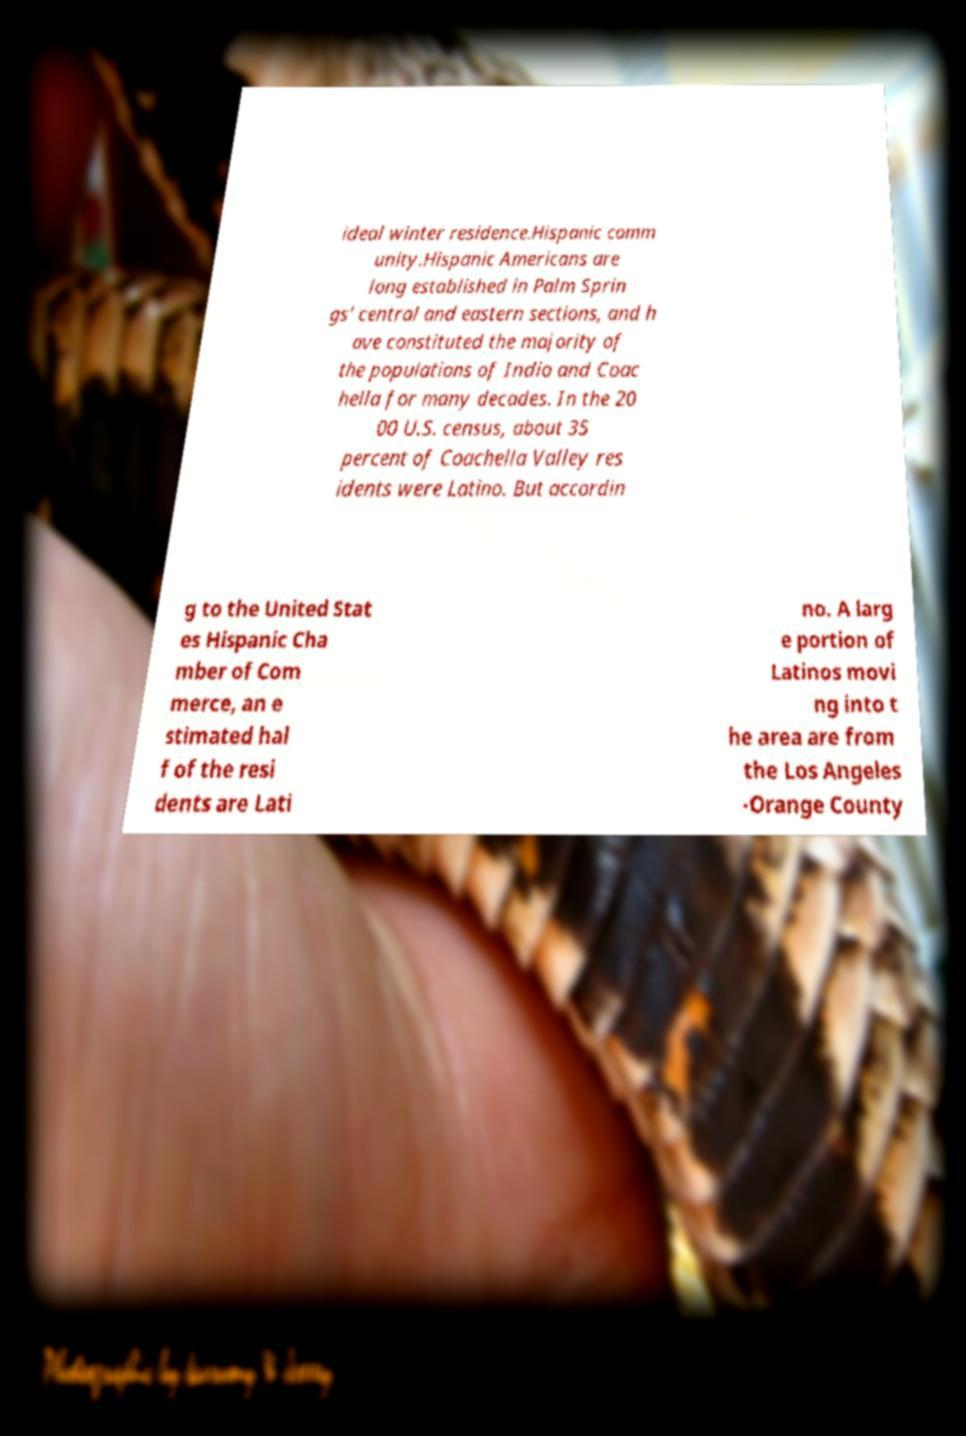I need the written content from this picture converted into text. Can you do that? ideal winter residence.Hispanic comm unity.Hispanic Americans are long established in Palm Sprin gs' central and eastern sections, and h ave constituted the majority of the populations of Indio and Coac hella for many decades. In the 20 00 U.S. census, about 35 percent of Coachella Valley res idents were Latino. But accordin g to the United Stat es Hispanic Cha mber of Com merce, an e stimated hal f of the resi dents are Lati no. A larg e portion of Latinos movi ng into t he area are from the Los Angeles -Orange County 